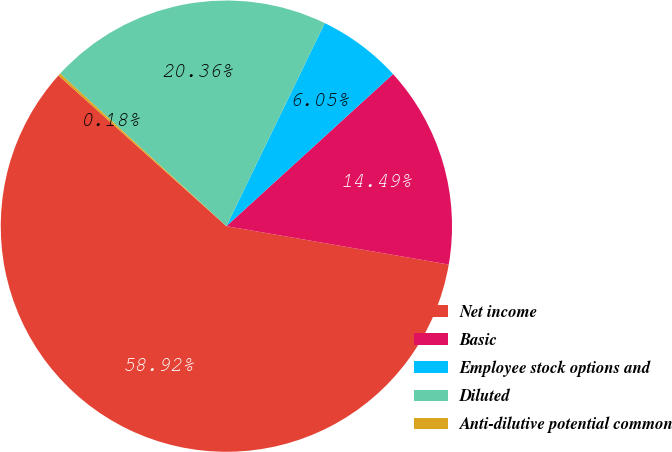Convert chart to OTSL. <chart><loc_0><loc_0><loc_500><loc_500><pie_chart><fcel>Net income<fcel>Basic<fcel>Employee stock options and<fcel>Diluted<fcel>Anti-dilutive potential common<nl><fcel>58.92%<fcel>14.49%<fcel>6.05%<fcel>20.36%<fcel>0.18%<nl></chart> 